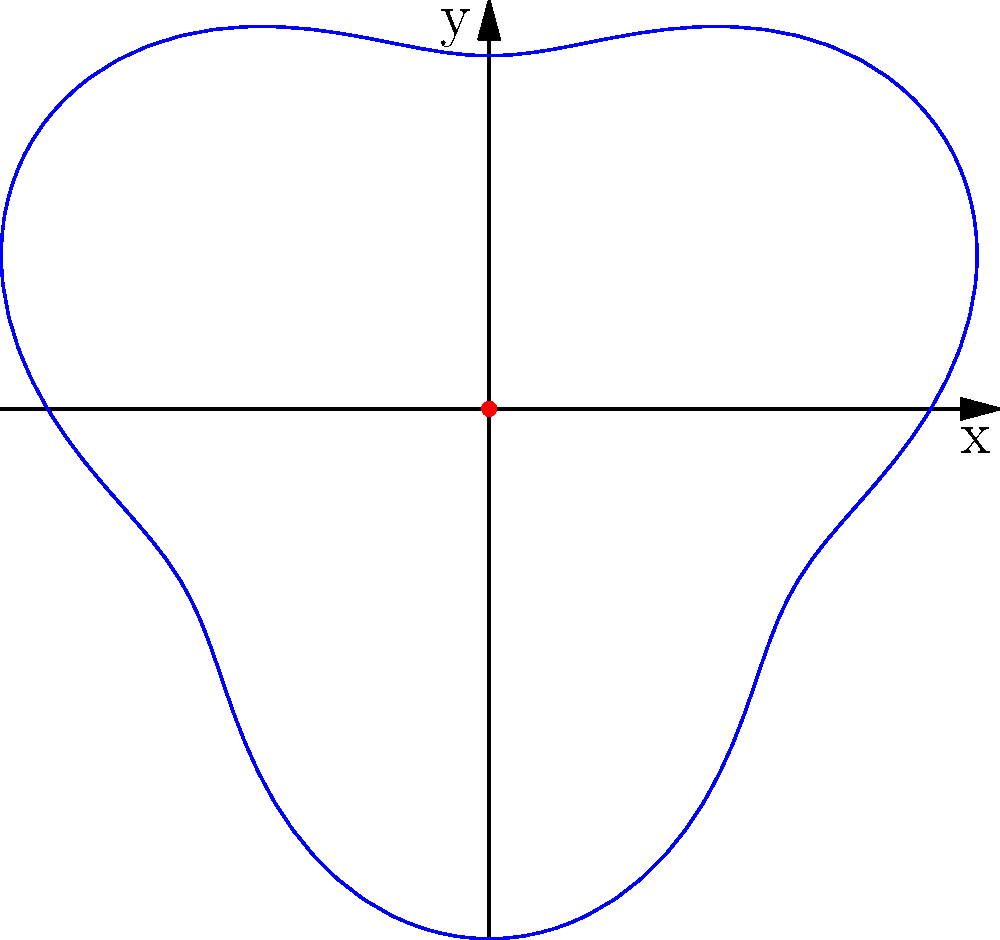Imagine you're helping a wizard map the shape of their magical wand using polar coordinates. The wand's shape is described by the equation $r = 5 + \sin(3\theta)$. What is the maximum length of the wand? Let's break this down step-by-step:

1. The equation $r = 5 + \sin(3\theta)$ describes the shape of the wand in polar coordinates.

2. We know that $\sin$ function always gives values between -1 and 1.

3. When $\sin(3\theta)$ is at its maximum value of 1, the equation becomes:
   $r = 5 + 1 = 6$

4. When $\sin(3\theta)$ is at its minimum value of -1, the equation becomes:
   $r = 5 + (-1) = 4$

5. The wand's length varies between 4 and 6 units as $\theta$ changes.

6. Therefore, the maximum length of the wand is 6 units.

This occurs when $\sin(3\theta) = 1$, which happens multiple times as the wand curves around.
Answer: 6 units 